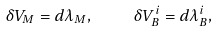Convert formula to latex. <formula><loc_0><loc_0><loc_500><loc_500>\delta V _ { M } = d \lambda _ { M } , \quad \delta V _ { B } ^ { i } = d \lambda _ { B } ^ { i } ,</formula> 